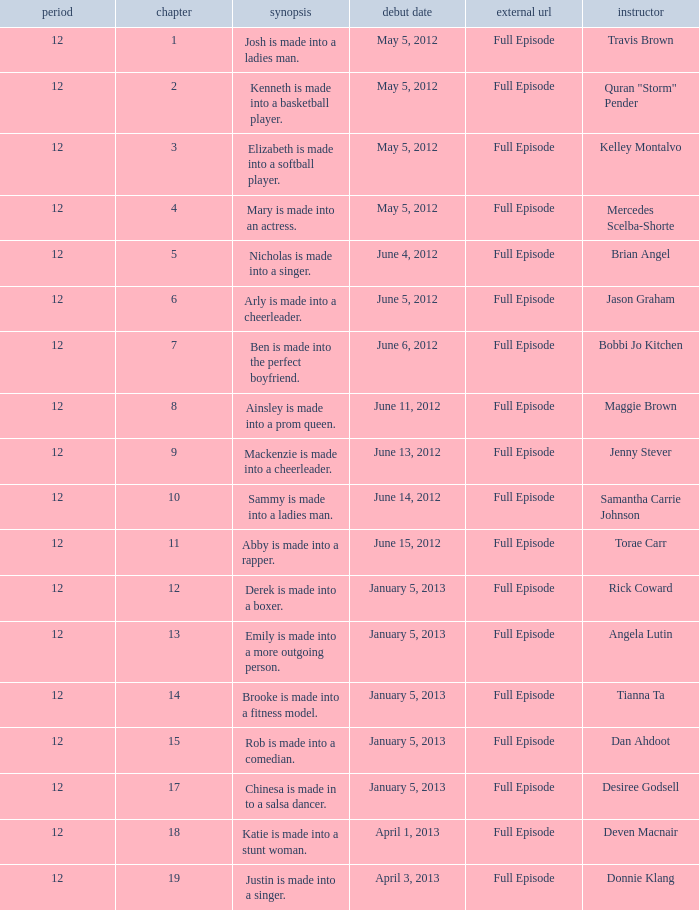Name the episode summary for torae carr Abby is made into a rapper. 